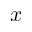Convert formula to latex. <formula><loc_0><loc_0><loc_500><loc_500>x</formula> 